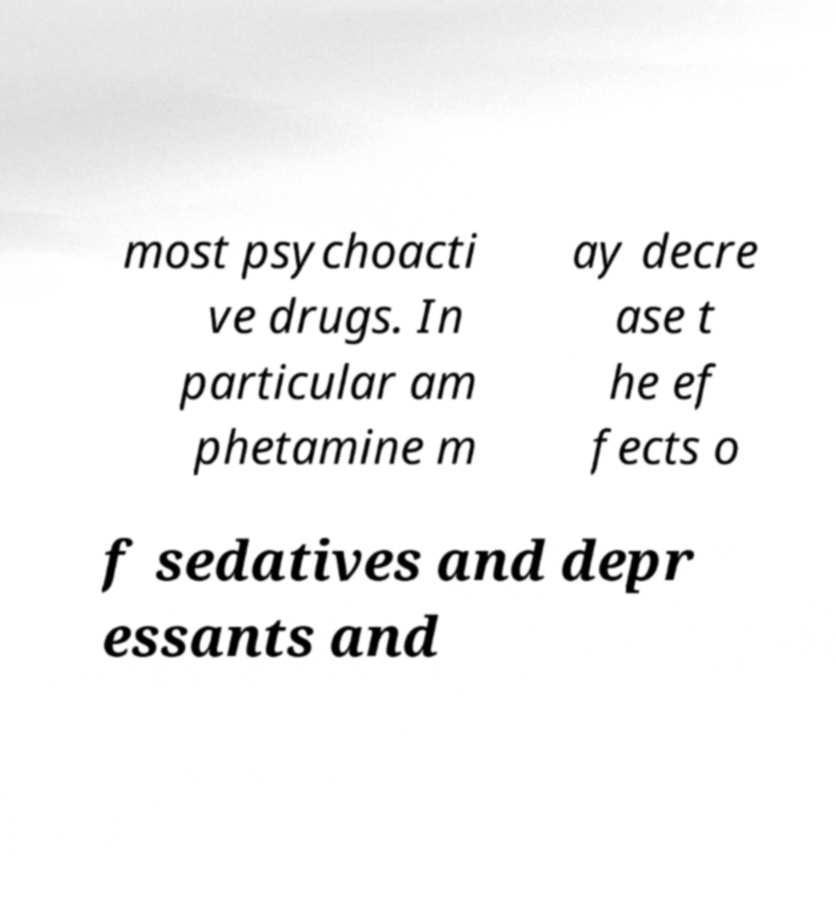Could you extract and type out the text from this image? most psychoacti ve drugs. In particular am phetamine m ay decre ase t he ef fects o f sedatives and depr essants and 